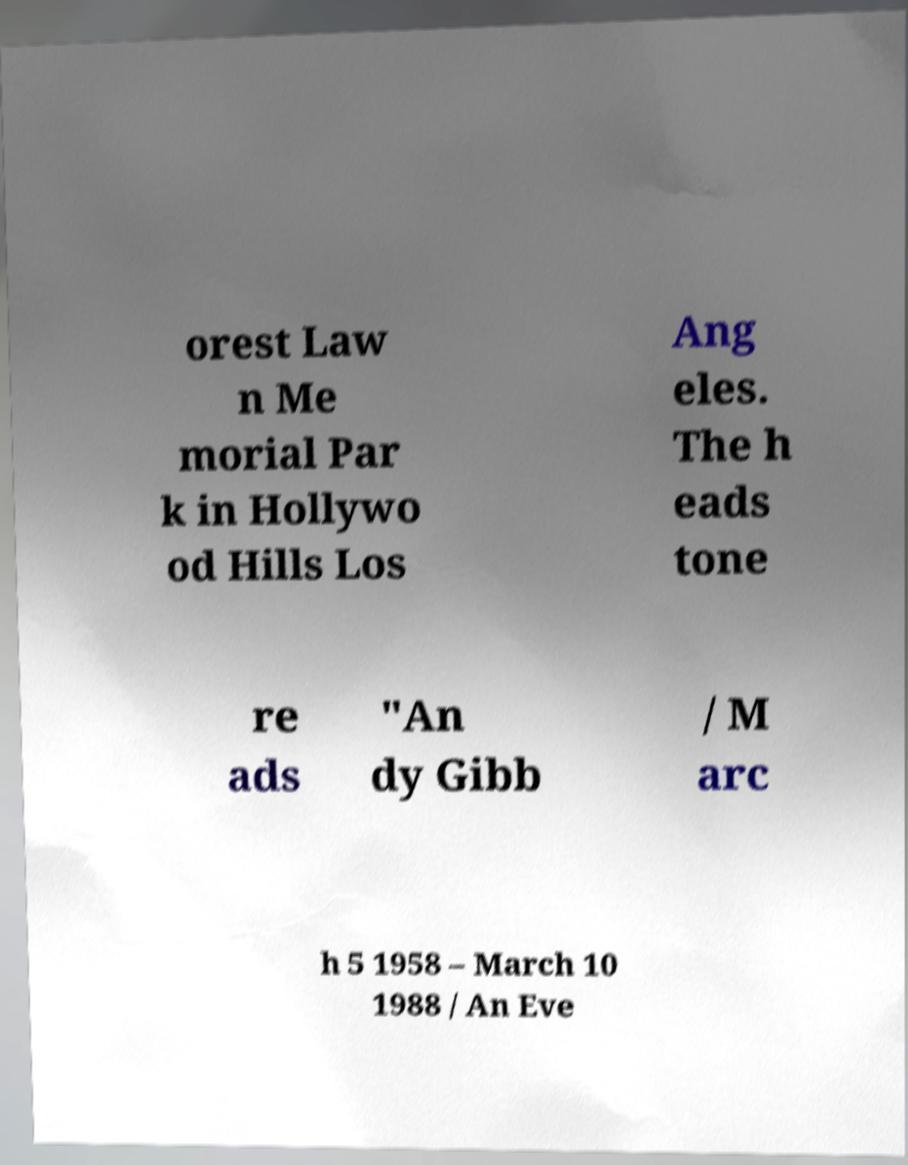Please read and relay the text visible in this image. What does it say? orest Law n Me morial Par k in Hollywo od Hills Los Ang eles. The h eads tone re ads "An dy Gibb / M arc h 5 1958 – March 10 1988 / An Eve 